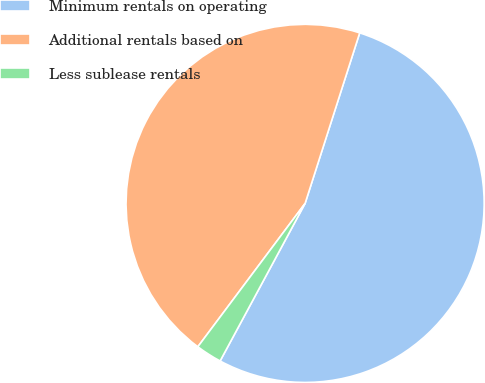Convert chart. <chart><loc_0><loc_0><loc_500><loc_500><pie_chart><fcel>Minimum rentals on operating<fcel>Additional rentals based on<fcel>Less sublease rentals<nl><fcel>52.94%<fcel>44.71%<fcel>2.35%<nl></chart> 